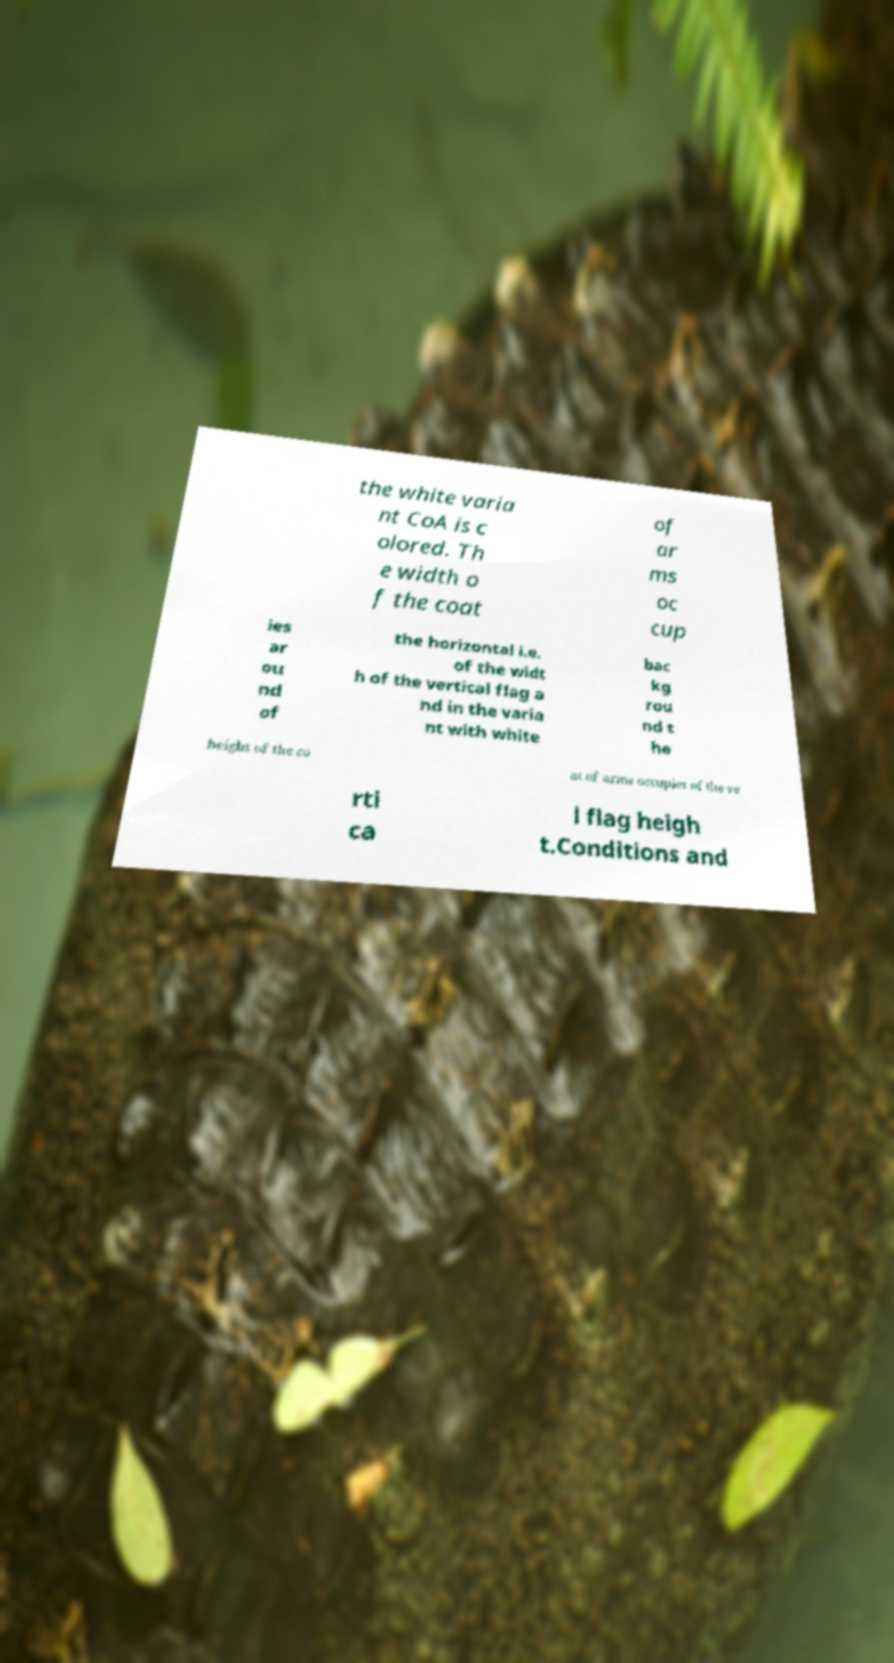Can you read and provide the text displayed in the image?This photo seems to have some interesting text. Can you extract and type it out for me? the white varia nt CoA is c olored. Th e width o f the coat of ar ms oc cup ies ar ou nd of the horizontal i.e. of the widt h of the vertical flag a nd in the varia nt with white bac kg rou nd t he height of the co at of arms occupies of the ve rti ca l flag heigh t.Conditions and 